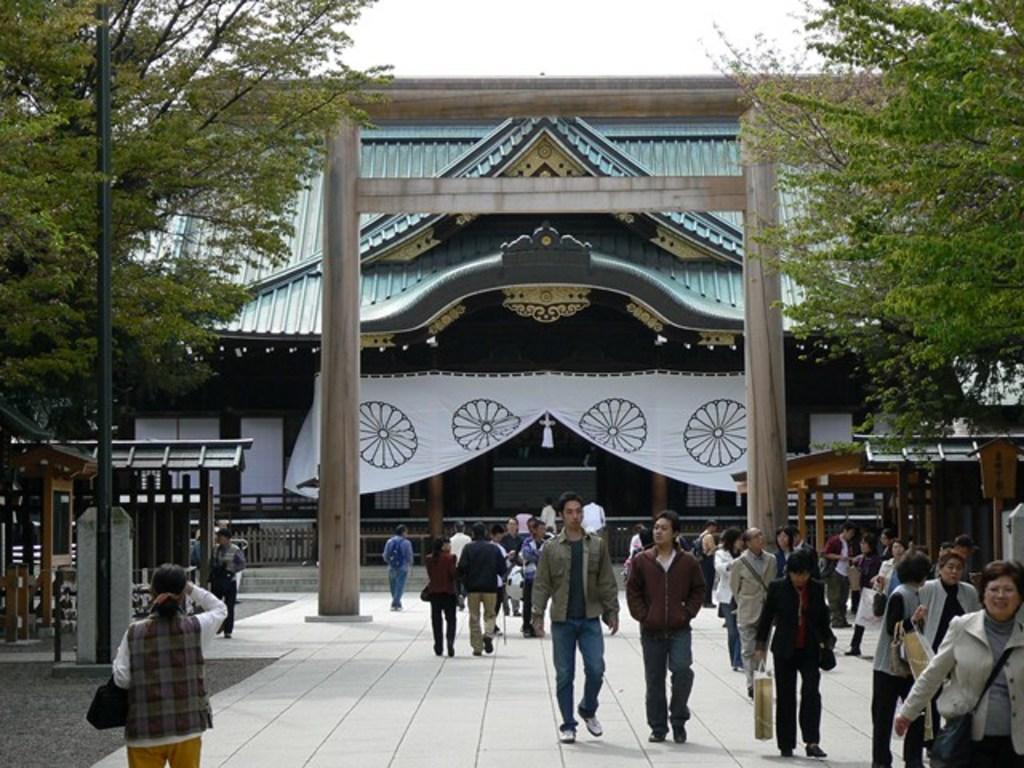Could you give a brief overview of what you see in this image? In this image, I can see groups of people walking and few people standing. It looks like a building with a roof. I can see a cloth hanging. I think this is a kind of an arch. On the left and right sides of the image, I can see the shelters and trees. At the bottom of the image, It looks like a pathway. 